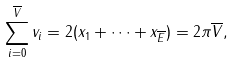<formula> <loc_0><loc_0><loc_500><loc_500>\sum _ { i = 0 } ^ { \overline { V } } v _ { i } = 2 ( x _ { 1 } + \dots + x _ { \overline { E } } ) = 2 \pi \overline { V } ,</formula> 